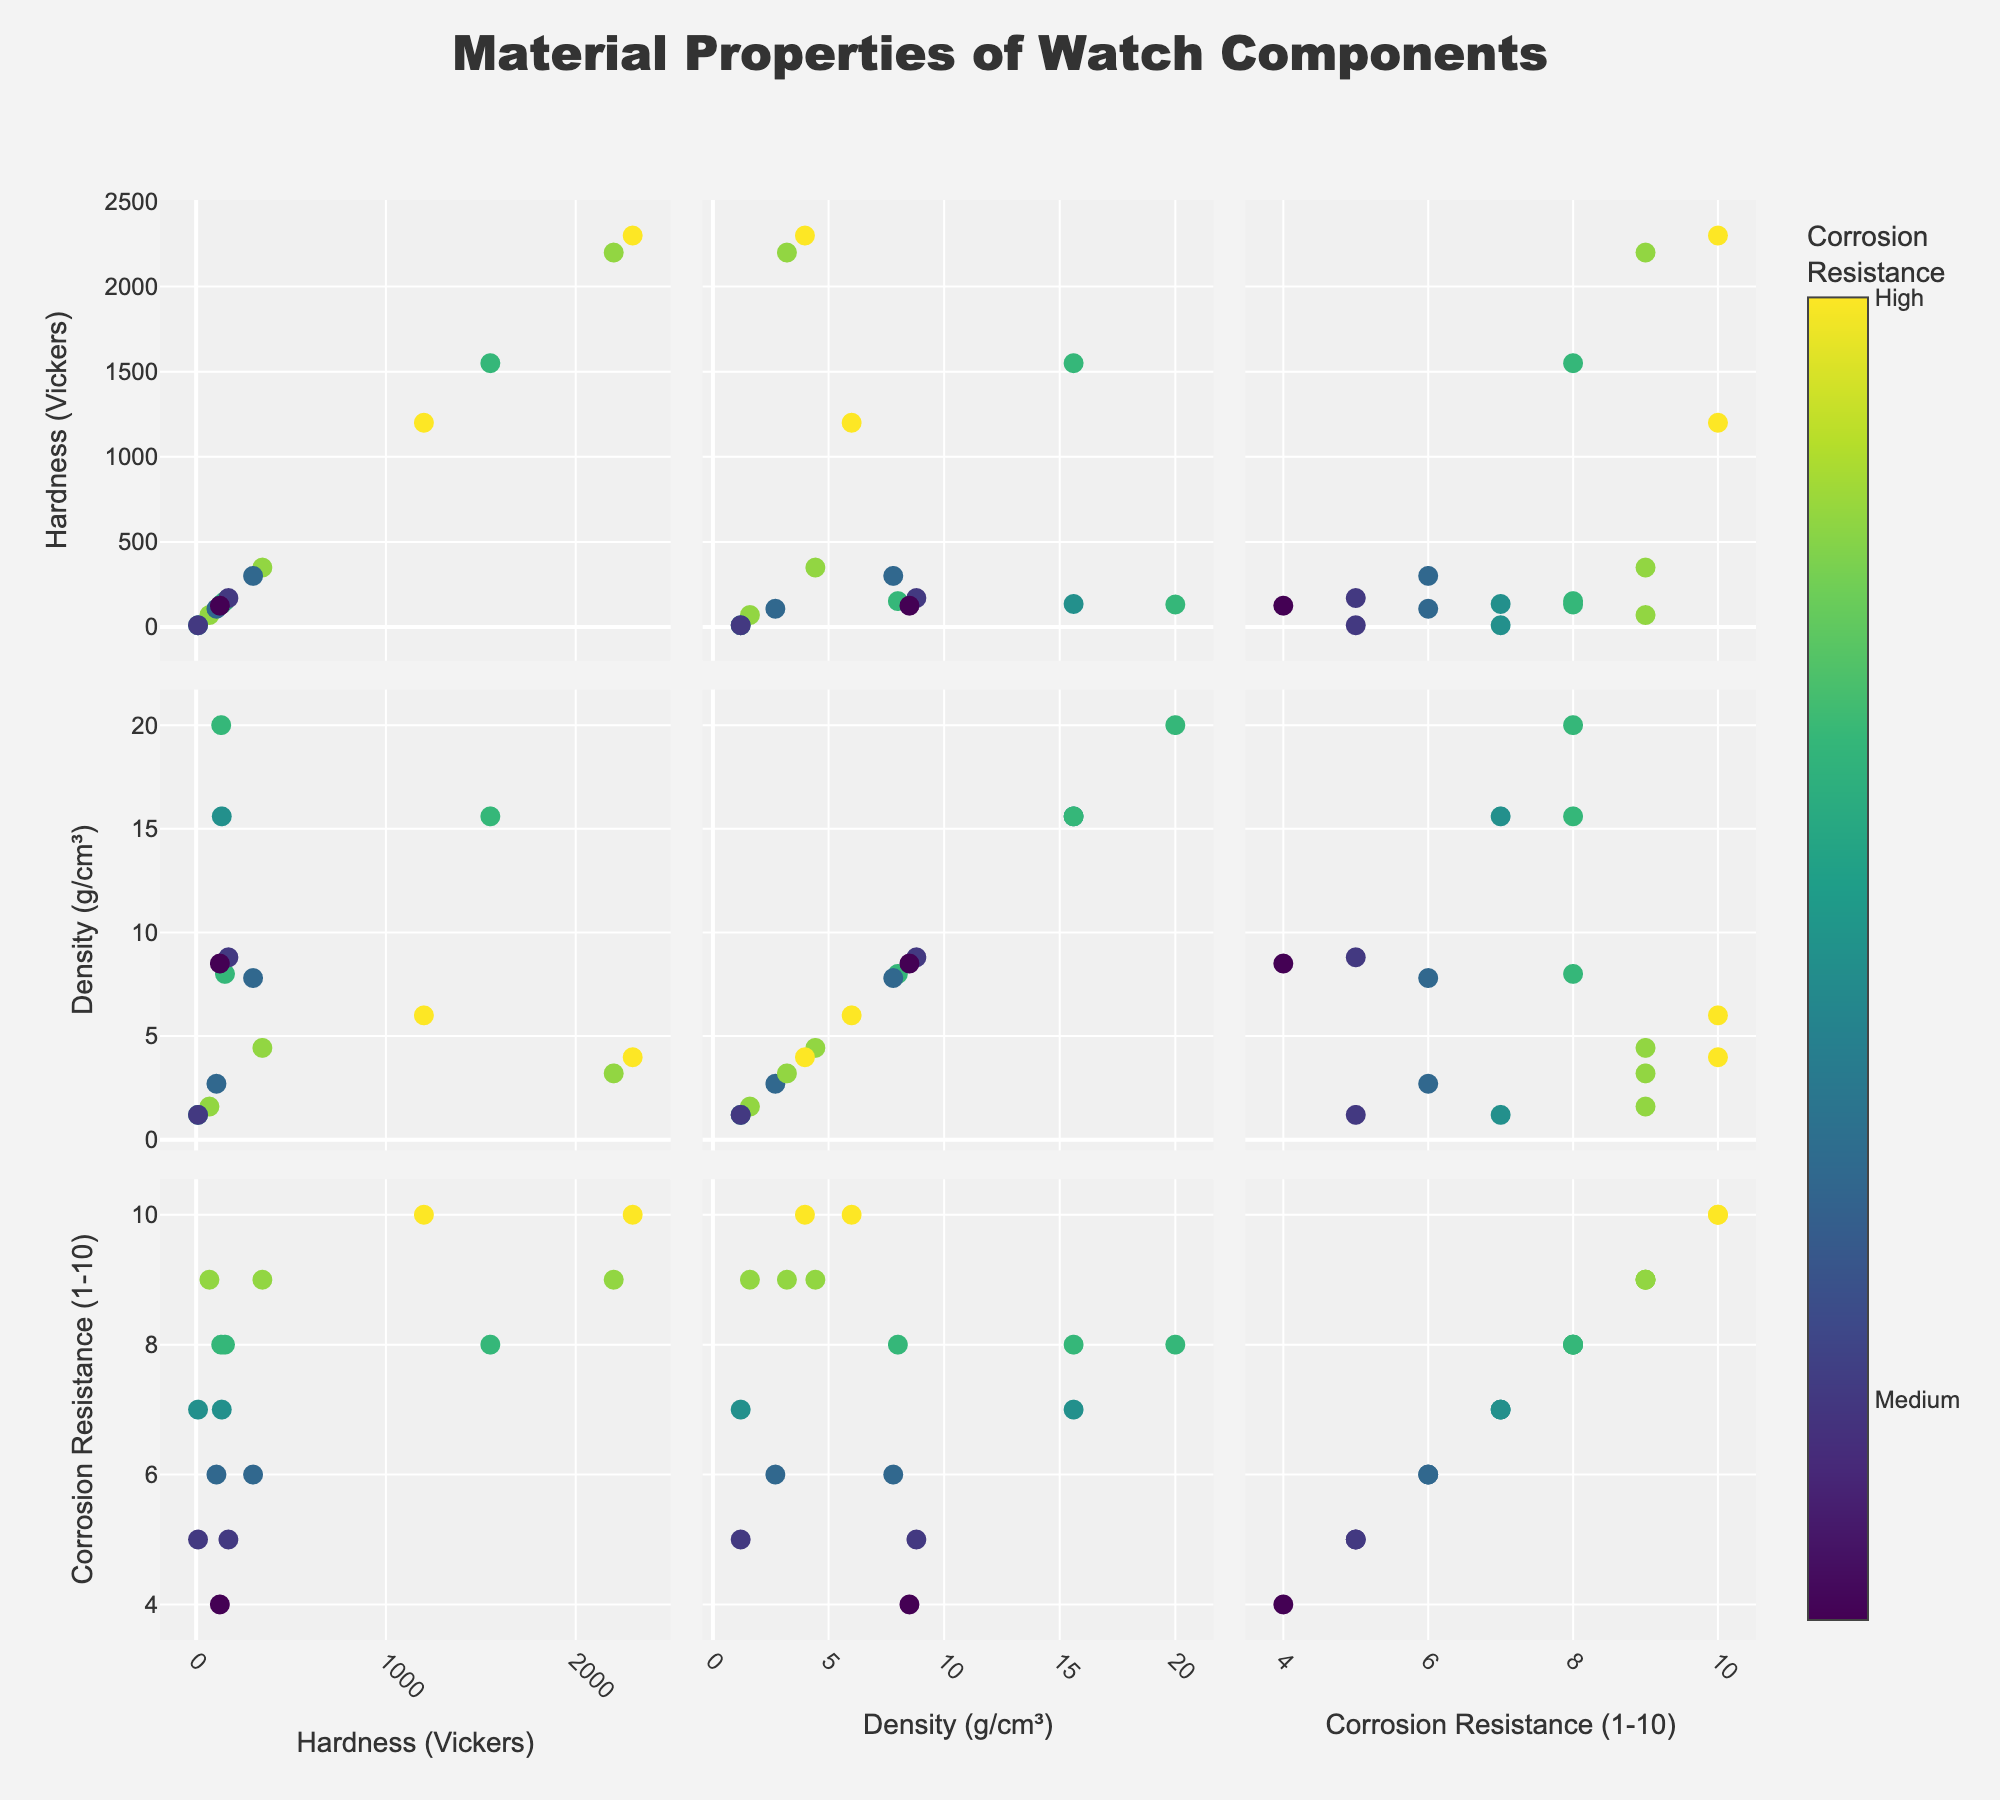What is the title of the figure? The title is displayed at the top of the figure, indicating what the plot is about.
Answer: Material Properties of Watch Components Which material has the highest hardness value? Locate the point with the highest y-value in the scatterplot where the vertical axis represents "Hardness (Vickers)".
Answer: PVD Coating Which two materials have the same lowest value of hardness? Identify points on the y-axis at the lowest position for "Hardness (Vickers)" and read their materials from the hover template.
Answer: Silicon Rubber and Polycarbonate What is the corrosion resistance rating of Titanium Grade 5? Hover over the point corresponding to Titanium Grade 5 and read the corrosion resistance value.
Answer: 9 Which material appears to have the lowest density? Identify the point on the horizontal axis labeled "Density (g/cm³)" with the lowest value and find its corresponding material.
Answer: Silicon Rubber What can be said about the relationship between density and hardness? Examine the scatterplots involving density and hardness; observe if materials with high density correspond to high hardness or vice versa.
Answer: No clear correlation Considering density and corrosion resistance, which material shows a balance between the two properties? Look for materials with moderate density and high corrosion resistance; use hover templates to check values.
Answer: Titanium Grade 5 Which material has the highest corrosion resistance and what is its hardness? Locate the highest point on the "Correlation Resistance (1-10)" axis and read its respective hardness value using hover.
Answer: Ceramic Zirconia, Hardness: 1200 Is there a clear pattern between high hardness and high corrosion resistance? Examine the scatterplot involving hardness and corrosion resistance; observe clustering trends or correlations.
Answer: No clear pattern 